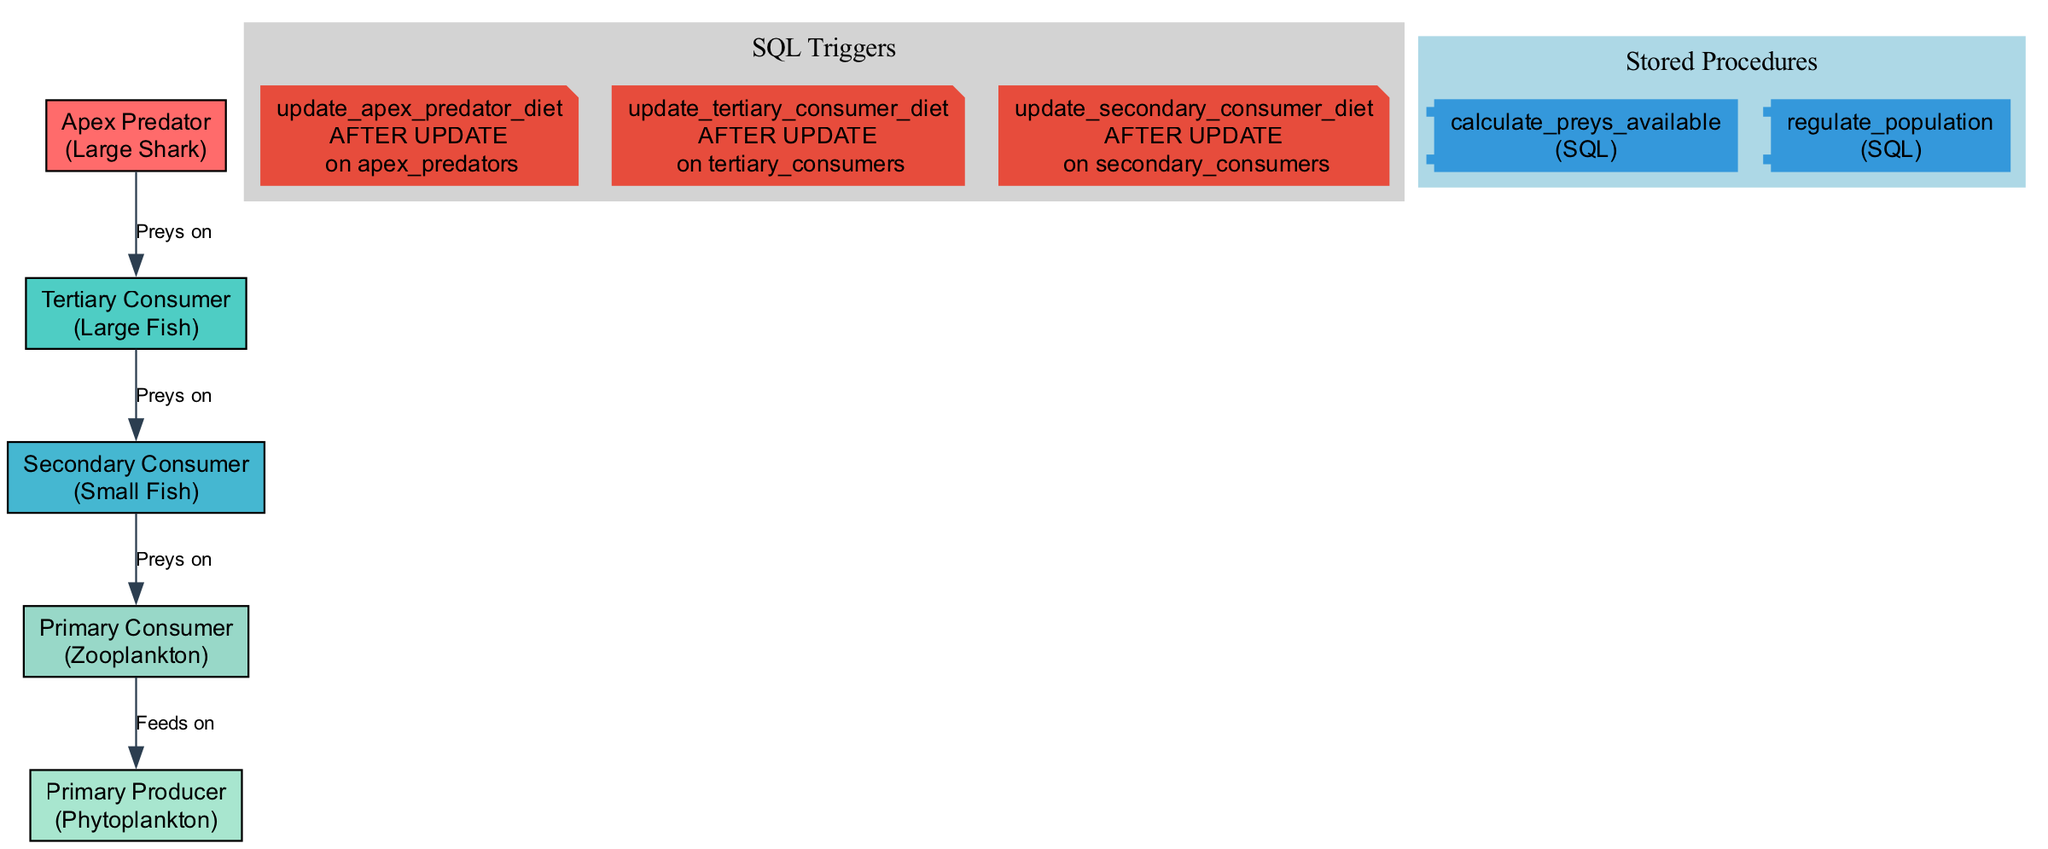What is the apex predator in this food chain? The diagram specifies that the apex predator is identified as "Large Shark." This information is obtained directly from the node labeled "Apex Predator."
Answer: Large Shark How many nodes are there in the marine food chain? By counting the nodes listed in the diagram, we find five distinct entities: Apex Predator, Tertiary Consumer, Secondary Consumer, Primary Consumer, and Primary Producer.
Answer: 5 Who preys on the tertiary consumer? The edge labeled "Preys on" indicates that the "Apex Predator" consumes "Large Fish," which identifies the apex predator as the one preying on the tertiary consumer. This relationship is directly visualized in the edges of the diagram.
Answer: Apex Predator What is the primary consumer in this food chain? The diagram's node list includes the "Primary Consumer," which is defined as "Zooplankton." This information can be directly recognized from the node labeled "Primary Consumer."
Answer: Zooplankton What happens in the stored procedure named 'RegulatePopulation'? The explanation of the stored procedure outlines that it aims to delete from both "tertiary_consumers" where the population exceeds 1000 and "secondary_consumers" where the population exceeds 10000, hence regulating their populations.
Answer: Deletes excess consumers Which SQL trigger updates the diet of the apex predator? The diagram indicates that the trigger named "update_apex_predator_diet" is responsible for updating the apex predator's diet to include "Large Fish," specifically when the species is identified as "Shark."
Answer: update_apex_predator_diet What is the role of the primary producer? The diagram indicates that the "Primary Producer," which is "Phytoplankton," serves as the base source of energy, providing food for the primary consumer, indicating its foundational role in the food chain.
Answer: Phytoplankton How many SQL triggers are shown in the diagram? By reviewing the diagram, we find that there are three SQL triggers present, labeled distinctly for updating the diets of apex predators, tertiary consumers, and secondary consumers.
Answer: 3 What does the edge label 'Preys on' signify? The edge labels such as "Preys on" convey the predatory relationships among the different consumer levels in the food chain, defining which organisms are consumed by others in the marine ecosystem.
Answer: Predatory relationships 